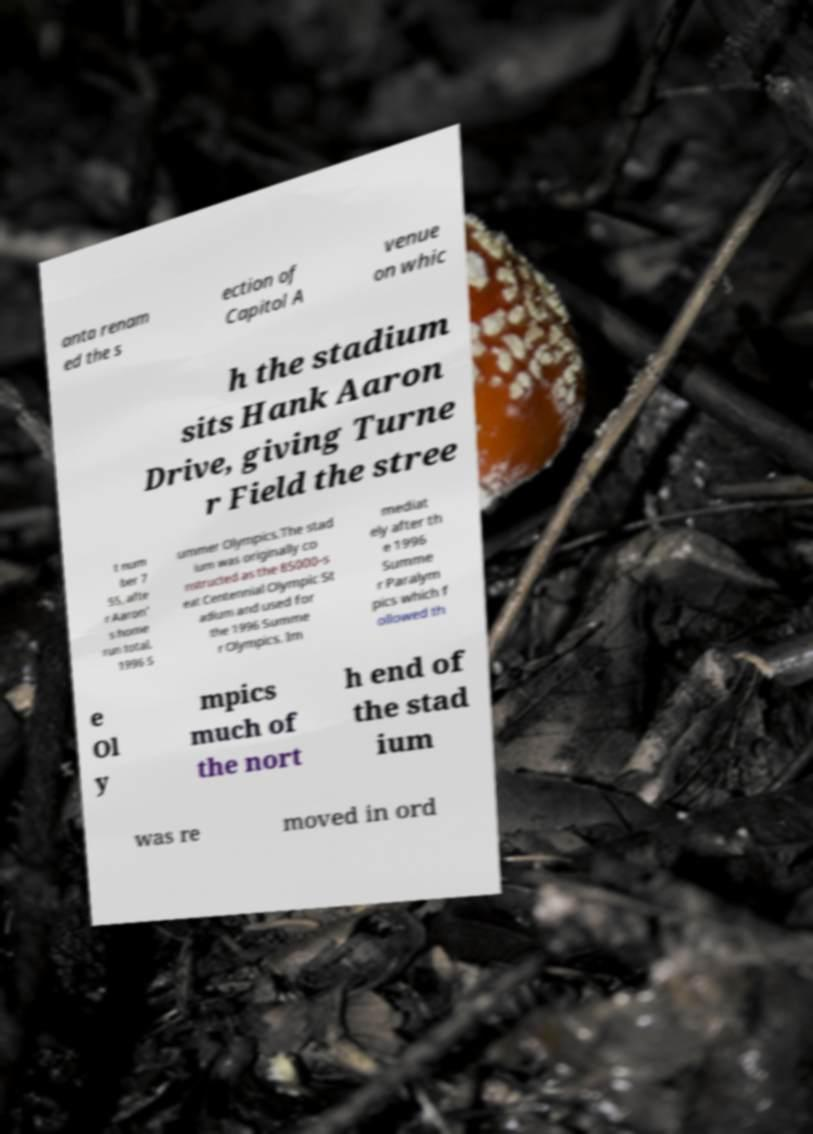Please identify and transcribe the text found in this image. anta renam ed the s ection of Capitol A venue on whic h the stadium sits Hank Aaron Drive, giving Turne r Field the stree t num ber 7 55, afte r Aaron' s home run total. 1996 S ummer Olympics.The stad ium was originally co nstructed as the 85000-s eat Centennial Olympic St adium and used for the 1996 Summe r Olympics. Im mediat ely after th e 1996 Summe r Paralym pics which f ollowed th e Ol y mpics much of the nort h end of the stad ium was re moved in ord 